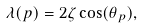<formula> <loc_0><loc_0><loc_500><loc_500>\lambda ( p ) = 2 \zeta \cos ( \theta _ { p } ) ,</formula> 